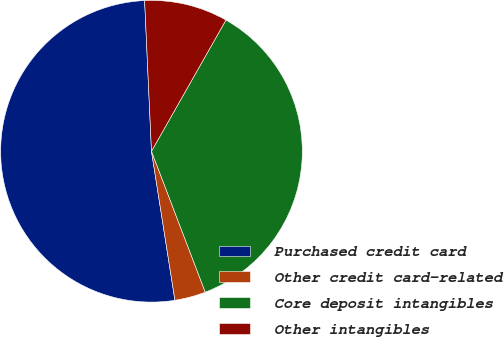Convert chart to OTSL. <chart><loc_0><loc_0><loc_500><loc_500><pie_chart><fcel>Purchased credit card<fcel>Other credit card-related<fcel>Core deposit intangibles<fcel>Other intangibles<nl><fcel>51.76%<fcel>3.32%<fcel>35.98%<fcel>8.94%<nl></chart> 